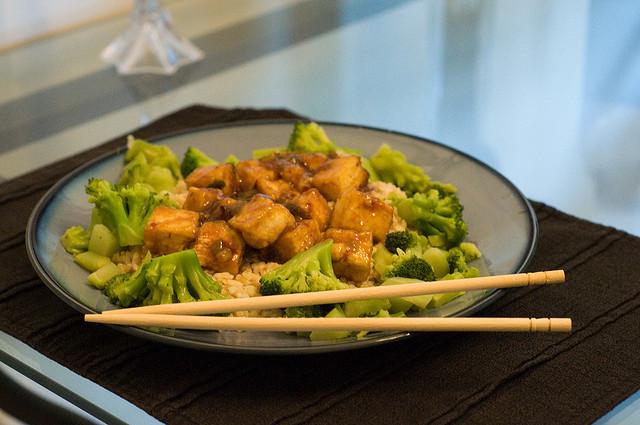Are we supposed to eat with a fork?
Keep it brief. No. Is this chinese?
Keep it brief. Yes. What are these eating utensils called?
Keep it brief. Chopsticks. What is the topping on the dish?
Write a very short answer. Chicken. 